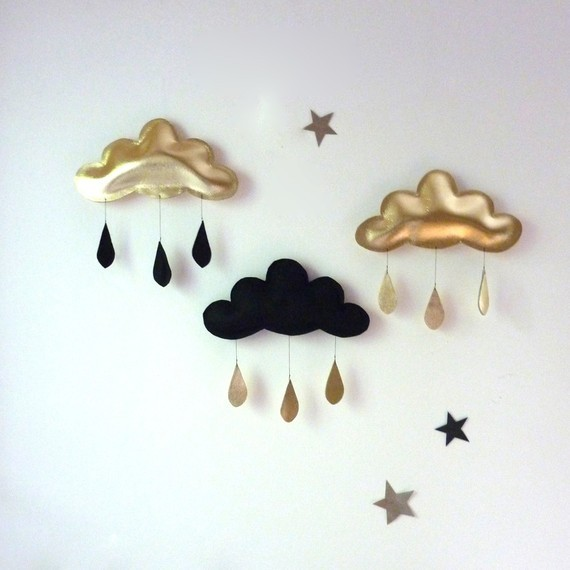How could the placement of these clouds and stars be interpreted in terms of spatial arrangement or compositional balance? The positioning of the clouds and stars appears deliberate, creating an asymmetrical but balanced composition. The three clouds are placed at varying heights, with the black cloud lower and centered, perhaps drawing the eye towards it as a focal point. The golden clouds seem to flank it, bringing harmony and framing the scene. The stars are scattered unevenly, contributing to a sense of whimsy and randomness, much like the actual night sky, which contrasts with the very structured arrangement of the clouds. This suggests a dichotomy between order and chaos, and might reflect the unpredictable nature of the universe juxtaposed with the human desire for structure and harmony. 